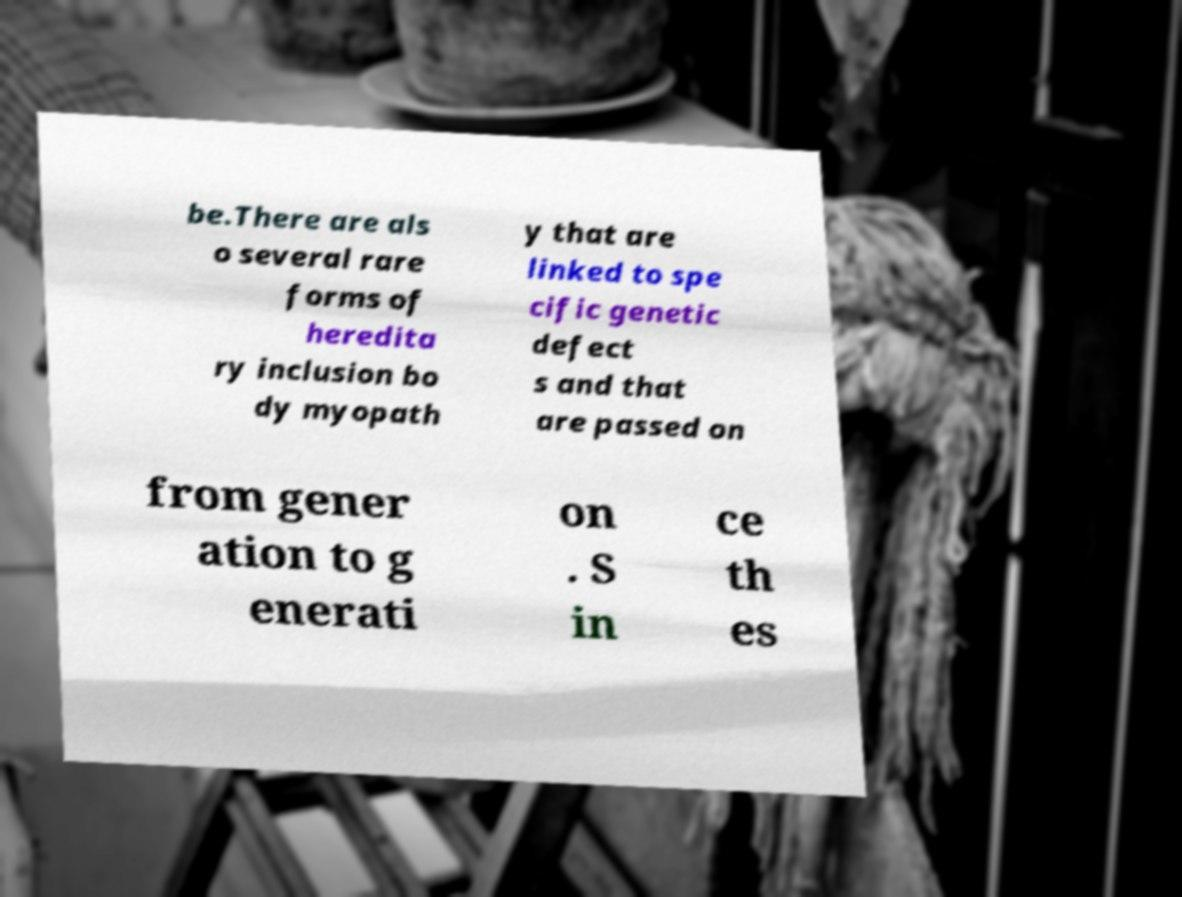Please identify and transcribe the text found in this image. be.There are als o several rare forms of heredita ry inclusion bo dy myopath y that are linked to spe cific genetic defect s and that are passed on from gener ation to g enerati on . S in ce th es 